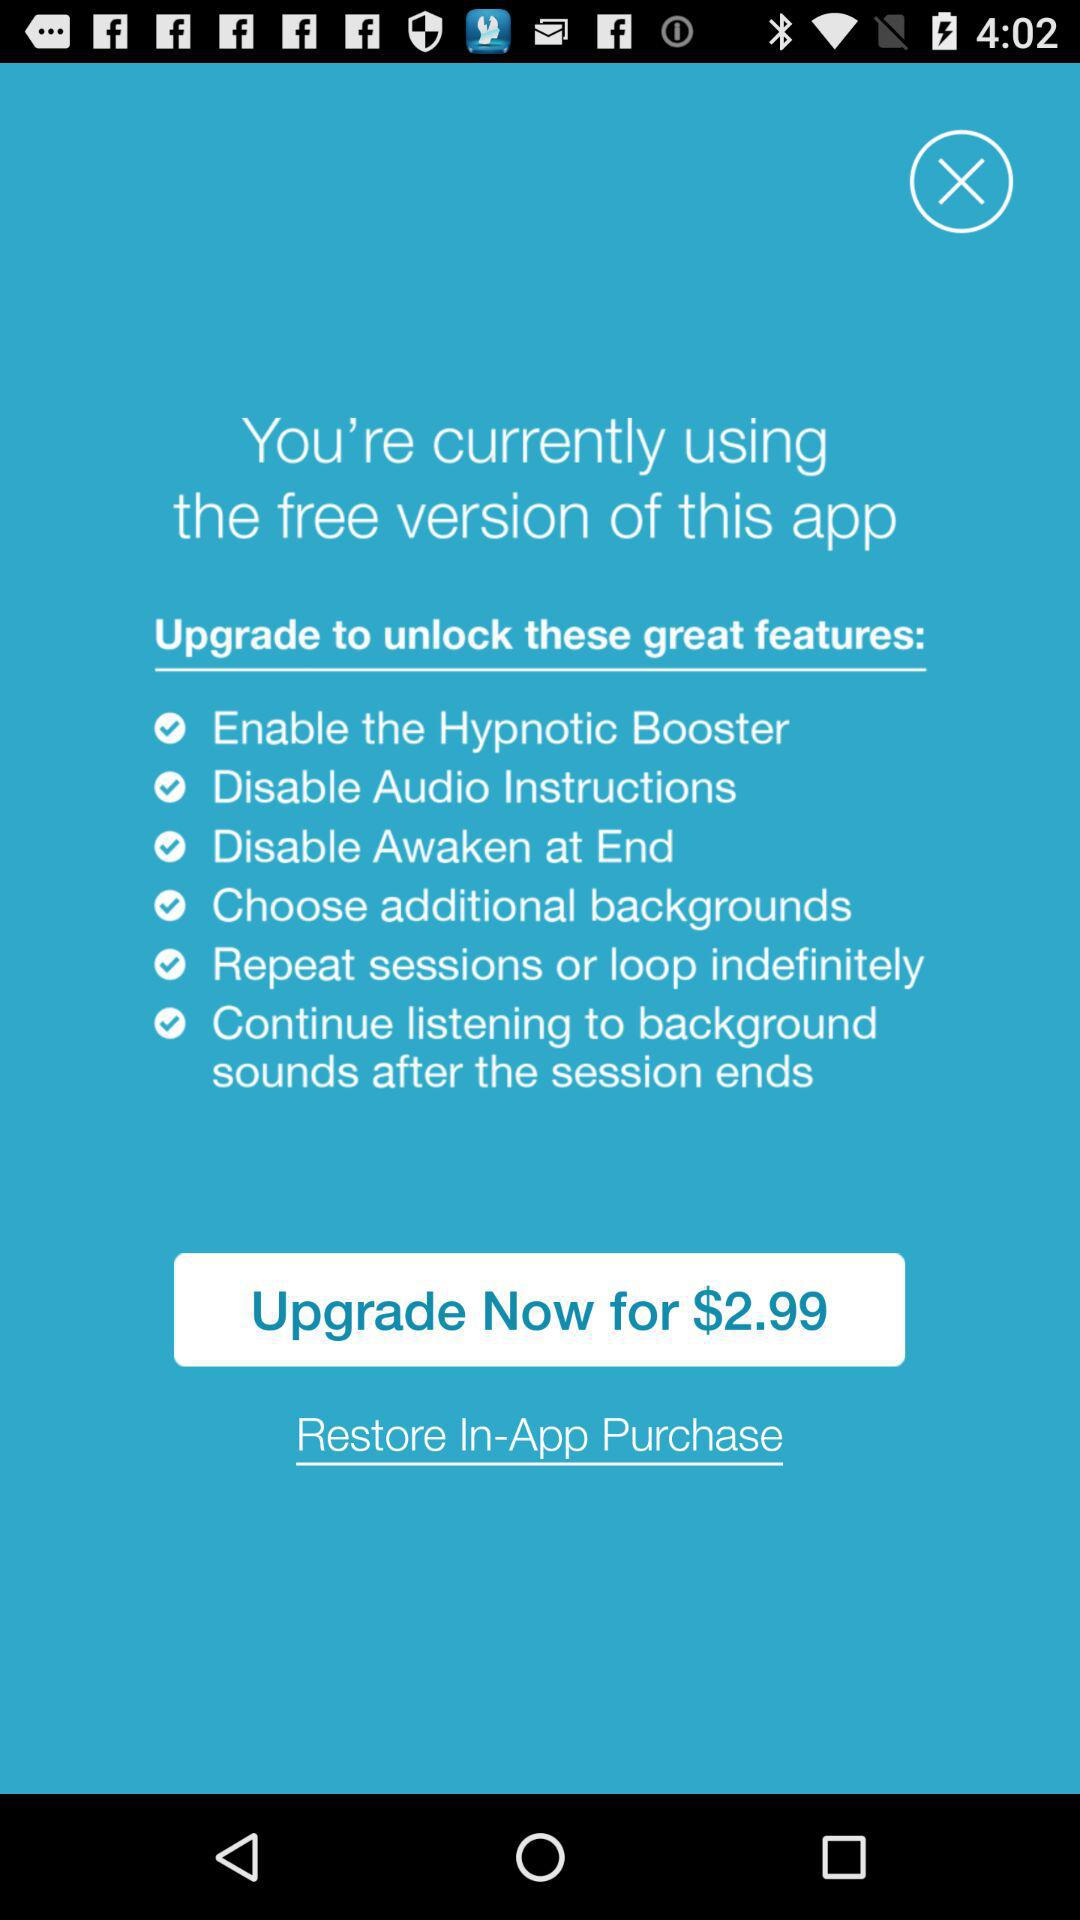How many features are unlocked by upgrading?
Answer the question using a single word or phrase. 6 